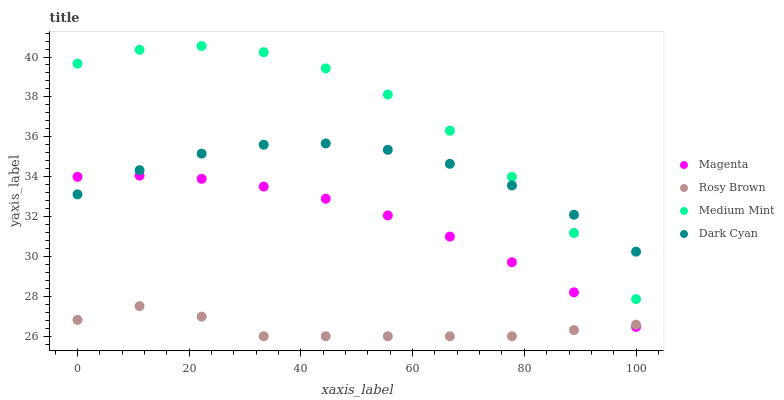Does Rosy Brown have the minimum area under the curve?
Answer yes or no. Yes. Does Medium Mint have the maximum area under the curve?
Answer yes or no. Yes. Does Dark Cyan have the minimum area under the curve?
Answer yes or no. No. Does Dark Cyan have the maximum area under the curve?
Answer yes or no. No. Is Magenta the smoothest?
Answer yes or no. Yes. Is Medium Mint the roughest?
Answer yes or no. Yes. Is Dark Cyan the smoothest?
Answer yes or no. No. Is Dark Cyan the roughest?
Answer yes or no. No. Does Rosy Brown have the lowest value?
Answer yes or no. Yes. Does Magenta have the lowest value?
Answer yes or no. No. Does Medium Mint have the highest value?
Answer yes or no. Yes. Does Dark Cyan have the highest value?
Answer yes or no. No. Is Rosy Brown less than Medium Mint?
Answer yes or no. Yes. Is Dark Cyan greater than Rosy Brown?
Answer yes or no. Yes. Does Magenta intersect Rosy Brown?
Answer yes or no. Yes. Is Magenta less than Rosy Brown?
Answer yes or no. No. Is Magenta greater than Rosy Brown?
Answer yes or no. No. Does Rosy Brown intersect Medium Mint?
Answer yes or no. No. 